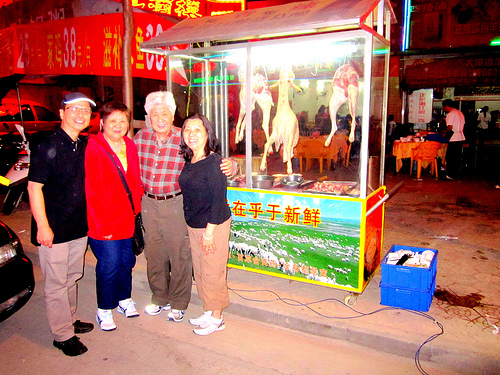<image>
Is there a woman next to the woman? No. The woman is not positioned next to the woman. They are located in different areas of the scene. 